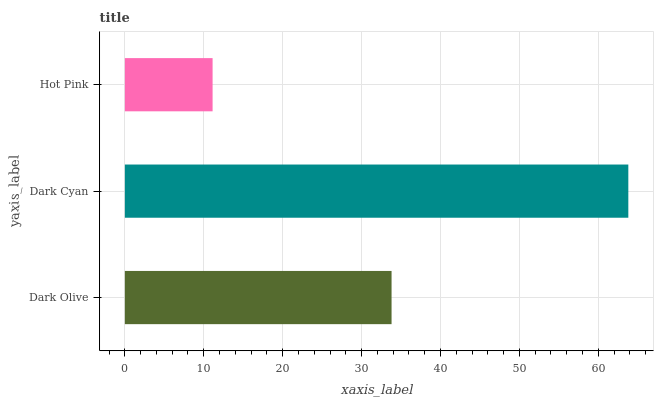Is Hot Pink the minimum?
Answer yes or no. Yes. Is Dark Cyan the maximum?
Answer yes or no. Yes. Is Dark Cyan the minimum?
Answer yes or no. No. Is Hot Pink the maximum?
Answer yes or no. No. Is Dark Cyan greater than Hot Pink?
Answer yes or no. Yes. Is Hot Pink less than Dark Cyan?
Answer yes or no. Yes. Is Hot Pink greater than Dark Cyan?
Answer yes or no. No. Is Dark Cyan less than Hot Pink?
Answer yes or no. No. Is Dark Olive the high median?
Answer yes or no. Yes. Is Dark Olive the low median?
Answer yes or no. Yes. Is Hot Pink the high median?
Answer yes or no. No. Is Hot Pink the low median?
Answer yes or no. No. 